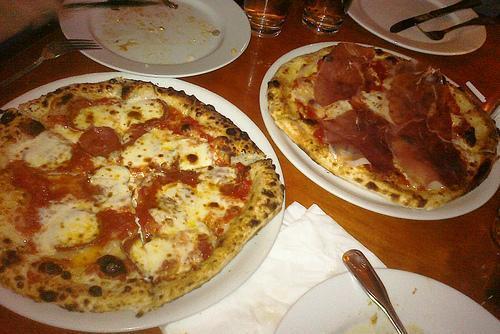How many plates have pizza?
Give a very brief answer. 2. 